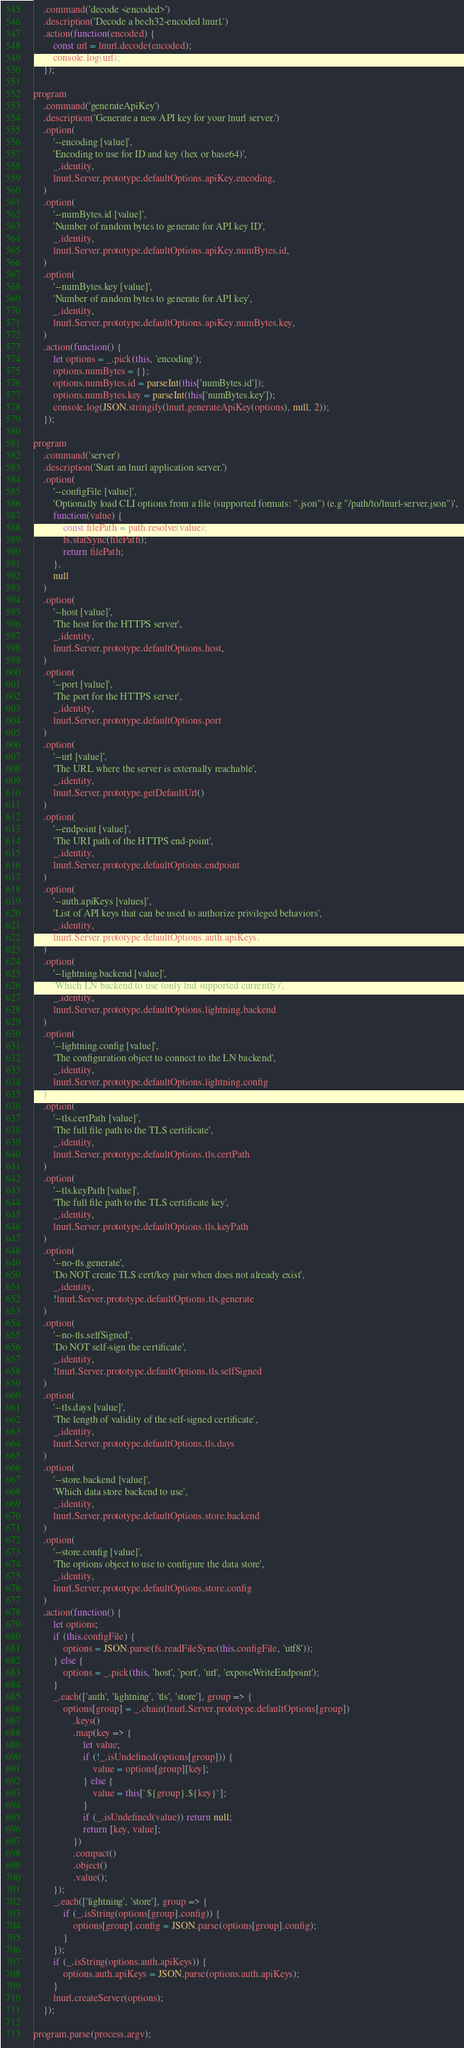Convert code to text. <code><loc_0><loc_0><loc_500><loc_500><_JavaScript_>	.command('decode <encoded>')
	.description('Decode a bech32-encoded lnurl.')
	.action(function(encoded) {
		const url = lnurl.decode(encoded);
		console.log(url);
	});

program
	.command('generateApiKey')
	.description('Generate a new API key for your lnurl server.')
	.option(
		'--encoding [value]',
		'Encoding to use for ID and key (hex or base64)',
		_.identity,
		lnurl.Server.prototype.defaultOptions.apiKey.encoding,
	)
	.option(
		'--numBytes.id [value]',
		'Number of random bytes to generate for API key ID',
		_.identity,
		lnurl.Server.prototype.defaultOptions.apiKey.numBytes.id,
	)
	.option(
		'--numBytes.key [value]',
		'Number of random bytes to generate for API key',
		_.identity,
		lnurl.Server.prototype.defaultOptions.apiKey.numBytes.key,
	)
	.action(function() {
		let options = _.pick(this, 'encoding');
		options.numBytes = {};
		options.numBytes.id = parseInt(this['numBytes.id']);
		options.numBytes.key = parseInt(this['numBytes.key']);
		console.log(JSON.stringify(lnurl.generateApiKey(options), null, 2));
	});

program
	.command('server')
	.description('Start an lnurl application server.')
	.option(
		'--configFile [value]',
		'Optionally load CLI options from a file (supported formats: ".json") (e.g "/path/to/lnurl-server.json")',
		function(value) {
			const filePath = path.resolve(value);
			fs.statSync(filePath);
			return filePath;
		},
		null
	)
	.option(
		'--host [value]',
		'The host for the HTTPS server',
		_.identity,
		lnurl.Server.prototype.defaultOptions.host,
	)
	.option(
		'--port [value]',
		'The port for the HTTPS server',
		_.identity,
		lnurl.Server.prototype.defaultOptions.port
	)
	.option(
		'--url [value]',
		'The URL where the server is externally reachable',
		_.identity,
		lnurl.Server.prototype.getDefaultUrl()
	)
	.option(
		'--endpoint [value]',
		'The URI path of the HTTPS end-point',
		_.identity,
		lnurl.Server.prototype.defaultOptions.endpoint
	)
	.option(
		'--auth.apiKeys [values]',
		'List of API keys that can be used to authorize privileged behaviors',
		_.identity,
		lnurl.Server.prototype.defaultOptions.auth.apiKeys,
	)
	.option(
		'--lightning.backend [value]',
		'Which LN backend to use (only lnd supported currently)',
		_.identity,
		lnurl.Server.prototype.defaultOptions.lightning.backend
	)
	.option(
		'--lightning.config [value]',
		'The configuration object to connect to the LN backend',
		_.identity,
		lnurl.Server.prototype.defaultOptions.lightning.config
	)
	.option(
		'--tls.certPath [value]',
		'The full file path to the TLS certificate',
		_.identity,
		lnurl.Server.prototype.defaultOptions.tls.certPath
	)
	.option(
		'--tls.keyPath [value]',
		'The full file path to the TLS certificate key',
		_.identity,
		lnurl.Server.prototype.defaultOptions.tls.keyPath
	)
	.option(
		'--no-tls.generate',
		'Do NOT create TLS cert/key pair when does not already exist',
		_.identity,
		!lnurl.Server.prototype.defaultOptions.tls.generate
	)
	.option(
		'--no-tls.selfSigned',
		'Do NOT self-sign the certificate',
		_.identity,
		!lnurl.Server.prototype.defaultOptions.tls.selfSigned
	)
	.option(
		'--tls.days [value]',
		'The length of validity of the self-signed certificate',
		_.identity,
		lnurl.Server.prototype.defaultOptions.tls.days
	)
	.option(
		'--store.backend [value]',
		'Which data store backend to use',
		_.identity,
		lnurl.Server.prototype.defaultOptions.store.backend
	)
	.option(
		'--store.config [value]',
		'The options object to use to configure the data store',
		_.identity,
		lnurl.Server.prototype.defaultOptions.store.config
	)
	.action(function() {
		let options;
		if (this.configFile) {
			options = JSON.parse(fs.readFileSync(this.configFile, 'utf8'));
		} else {
			options = _.pick(this, 'host', 'port', 'url', 'exposeWriteEndpoint');
		}
		_.each(['auth', 'lightning', 'tls', 'store'], group => {
			options[group] = _.chain(lnurl.Server.prototype.defaultOptions[group])
				.keys()
				.map(key => {
					let value;
					if (!_.isUndefined(options[group])) {
						value = options[group][key];
					} else {
						value = this[`${group}.${key}`];
					}
					if (_.isUndefined(value)) return null;
					return [key, value];
				})
				.compact()
				.object()
				.value();
		});
		_.each(['lightning', 'store'], group => {
			if (_.isString(options[group].config)) {
				options[group].config = JSON.parse(options[group].config);
			}
		});
		if (_.isString(options.auth.apiKeys)) {
			options.auth.apiKeys = JSON.parse(options.auth.apiKeys);
		}
		lnurl.createServer(options);
	});

program.parse(process.argv);
</code> 